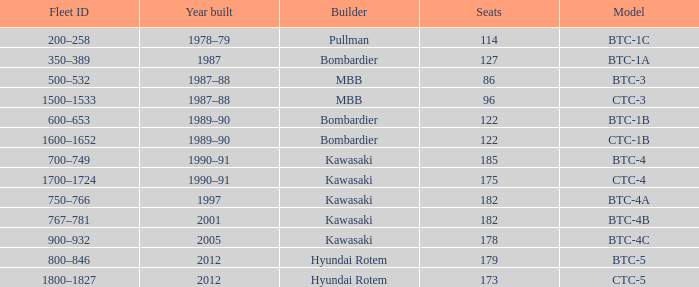In what year was the ctc-3 model developed? 1987–88. 